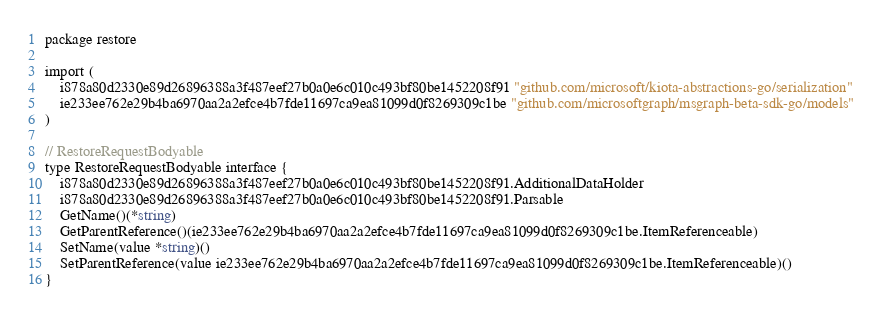Convert code to text. <code><loc_0><loc_0><loc_500><loc_500><_Go_>package restore

import (
    i878a80d2330e89d26896388a3f487eef27b0a0e6c010c493bf80be1452208f91 "github.com/microsoft/kiota-abstractions-go/serialization"
    ie233ee762e29b4ba6970aa2a2efce4b7fde11697ca9ea81099d0f8269309c1be "github.com/microsoftgraph/msgraph-beta-sdk-go/models"
)

// RestoreRequestBodyable 
type RestoreRequestBodyable interface {
    i878a80d2330e89d26896388a3f487eef27b0a0e6c010c493bf80be1452208f91.AdditionalDataHolder
    i878a80d2330e89d26896388a3f487eef27b0a0e6c010c493bf80be1452208f91.Parsable
    GetName()(*string)
    GetParentReference()(ie233ee762e29b4ba6970aa2a2efce4b7fde11697ca9ea81099d0f8269309c1be.ItemReferenceable)
    SetName(value *string)()
    SetParentReference(value ie233ee762e29b4ba6970aa2a2efce4b7fde11697ca9ea81099d0f8269309c1be.ItemReferenceable)()
}
</code> 